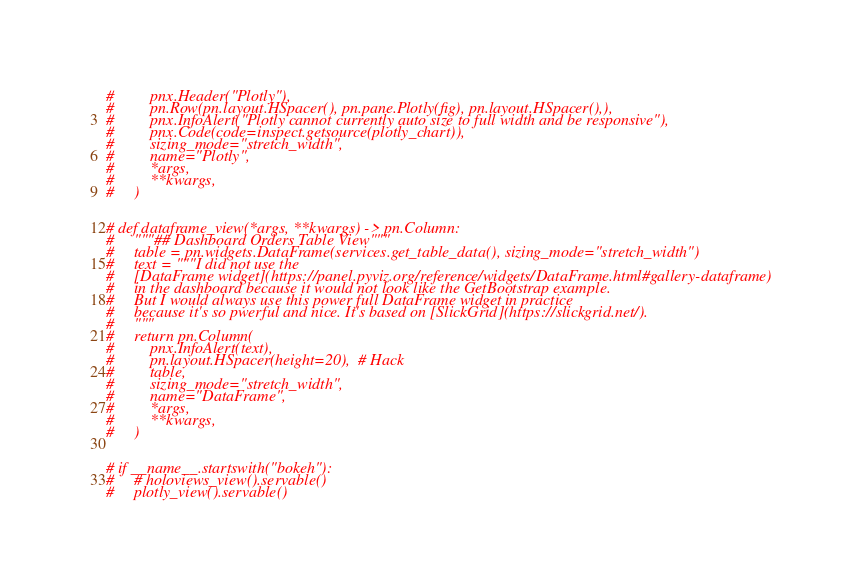Convert code to text. <code><loc_0><loc_0><loc_500><loc_500><_Python_>#         pnx.Header("Plotly"),
#         pn.Row(pn.layout.HSpacer(), pn.pane.Plotly(fig), pn.layout.HSpacer(),),
#         pnx.InfoAlert("Plotly cannot currently auto size to full width and be responsive"),
#         pnx.Code(code=inspect.getsource(plotly_chart)),
#         sizing_mode="stretch_width",
#         name="Plotly",
#         *args,
#         **kwargs,
#     )


# def dataframe_view(*args, **kwargs) -> pn.Column:
#     """## Dashboard Orders Table View"""
#     table = pn.widgets.DataFrame(services.get_table_data(), sizing_mode="stretch_width")
#     text = """I did not use the
#     [DataFrame widget](https://panel.pyviz.org/reference/widgets/DataFrame.html#gallery-dataframe)
#     in the dashboard because it would not look like the GetBootstrap example.
#     But I would always use this power full DataFrame widget in practice
#     because it's so pwerful and nice. It's based on [SlickGrid](https://slickgrid.net/).
#     """
#     return pn.Column(
#         pnx.InfoAlert(text),
#         pn.layout.HSpacer(height=20),  # Hack
#         table,
#         sizing_mode="stretch_width",
#         name="DataFrame",
#         *args,
#         **kwargs,
#     )


# if __name__.startswith("bokeh"):
#     # holoviews_view().servable()
#     plotly_view().servable()
</code> 